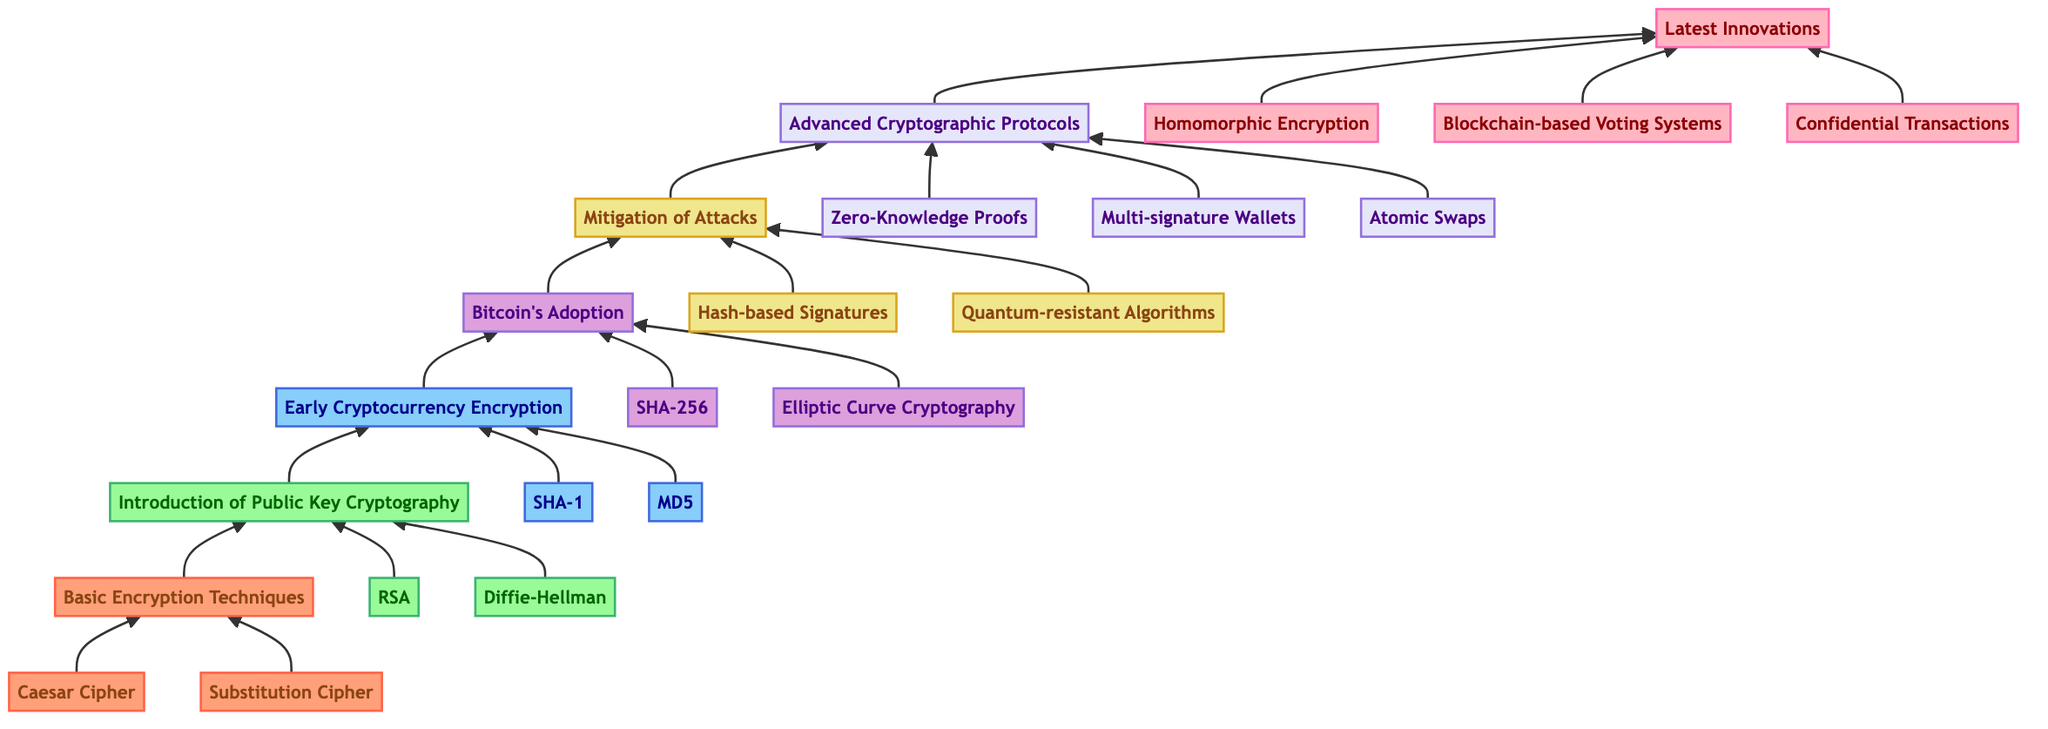What's the highest level in the flow chart? The highest level shown in the flow chart is level 7 labeled 'Latest Innovations'. It is the last node of the flow pointing upward, indicating the latest developments in the evolution of encryption algorithms in cryptocurrencies.
Answer: Latest Innovations How many levels are present in the diagram? The diagram consists of a total of 7 distinct levels, as represented by the different nodes from bottom to top. Each level signifies a phase in the evolution of encryption algorithms.
Answer: 7 What is the second component of level 4? The second component listed under level 4, which is ‘Bitcoin's Adoption’, is 'Elliptic Curve Cryptography'. This is reached by examining the components associated with that specific level.
Answer: Elliptic Curve Cryptography Which encryption technique is included in the lowest level? The lowest level, labeled as ‘Basic Encryption Techniques’, includes 'Caesar Cipher' and 'Substitution Cipher'. Looking directly at the components, we identify these as foundational techniques.
Answer: Caesar Cipher What is the primary focus of level 6? Level 6 focuses on 'Advanced Cryptographic Protocols', which includes advanced methodologies such as 'Zero-Knowledge Proofs', 'Multi-signature Wallets', and 'Atomic Swaps'. This level builds on previous technologies to incorporate more sophisticated solutions.
Answer: Advanced Cryptographic Protocols Which level comes immediately before 'Mitigation of Attacks'? The level directly preceding 'Mitigation of Attacks', which is level 5, is ‘Bitcoin's Adoption’. By tracing the flow upwards, this relationship is clearly depicted in the diagram.
Answer: Bitcoin's Adoption How many components does level 7 contain? Level 7 consists of three components: 'Homomorphic Encryption', 'Blockchain-based Voting Systems', and 'Confidential Transactions'. This is determined by counting the individual elements associated with that level.
Answer: 3 What is the relationship between 'Early Cryptocurrency Encryption' and 'Introduction of Public Key Cryptography'? 'Early Cryptocurrency Encryption' is considered level 3 and follows level 2, which is 'Introduction of Public Key Cryptography', indicating that the latter is foundational to the advancements in the former. The flow shows this direct developmental relationship.
Answer: Sequential relationship 